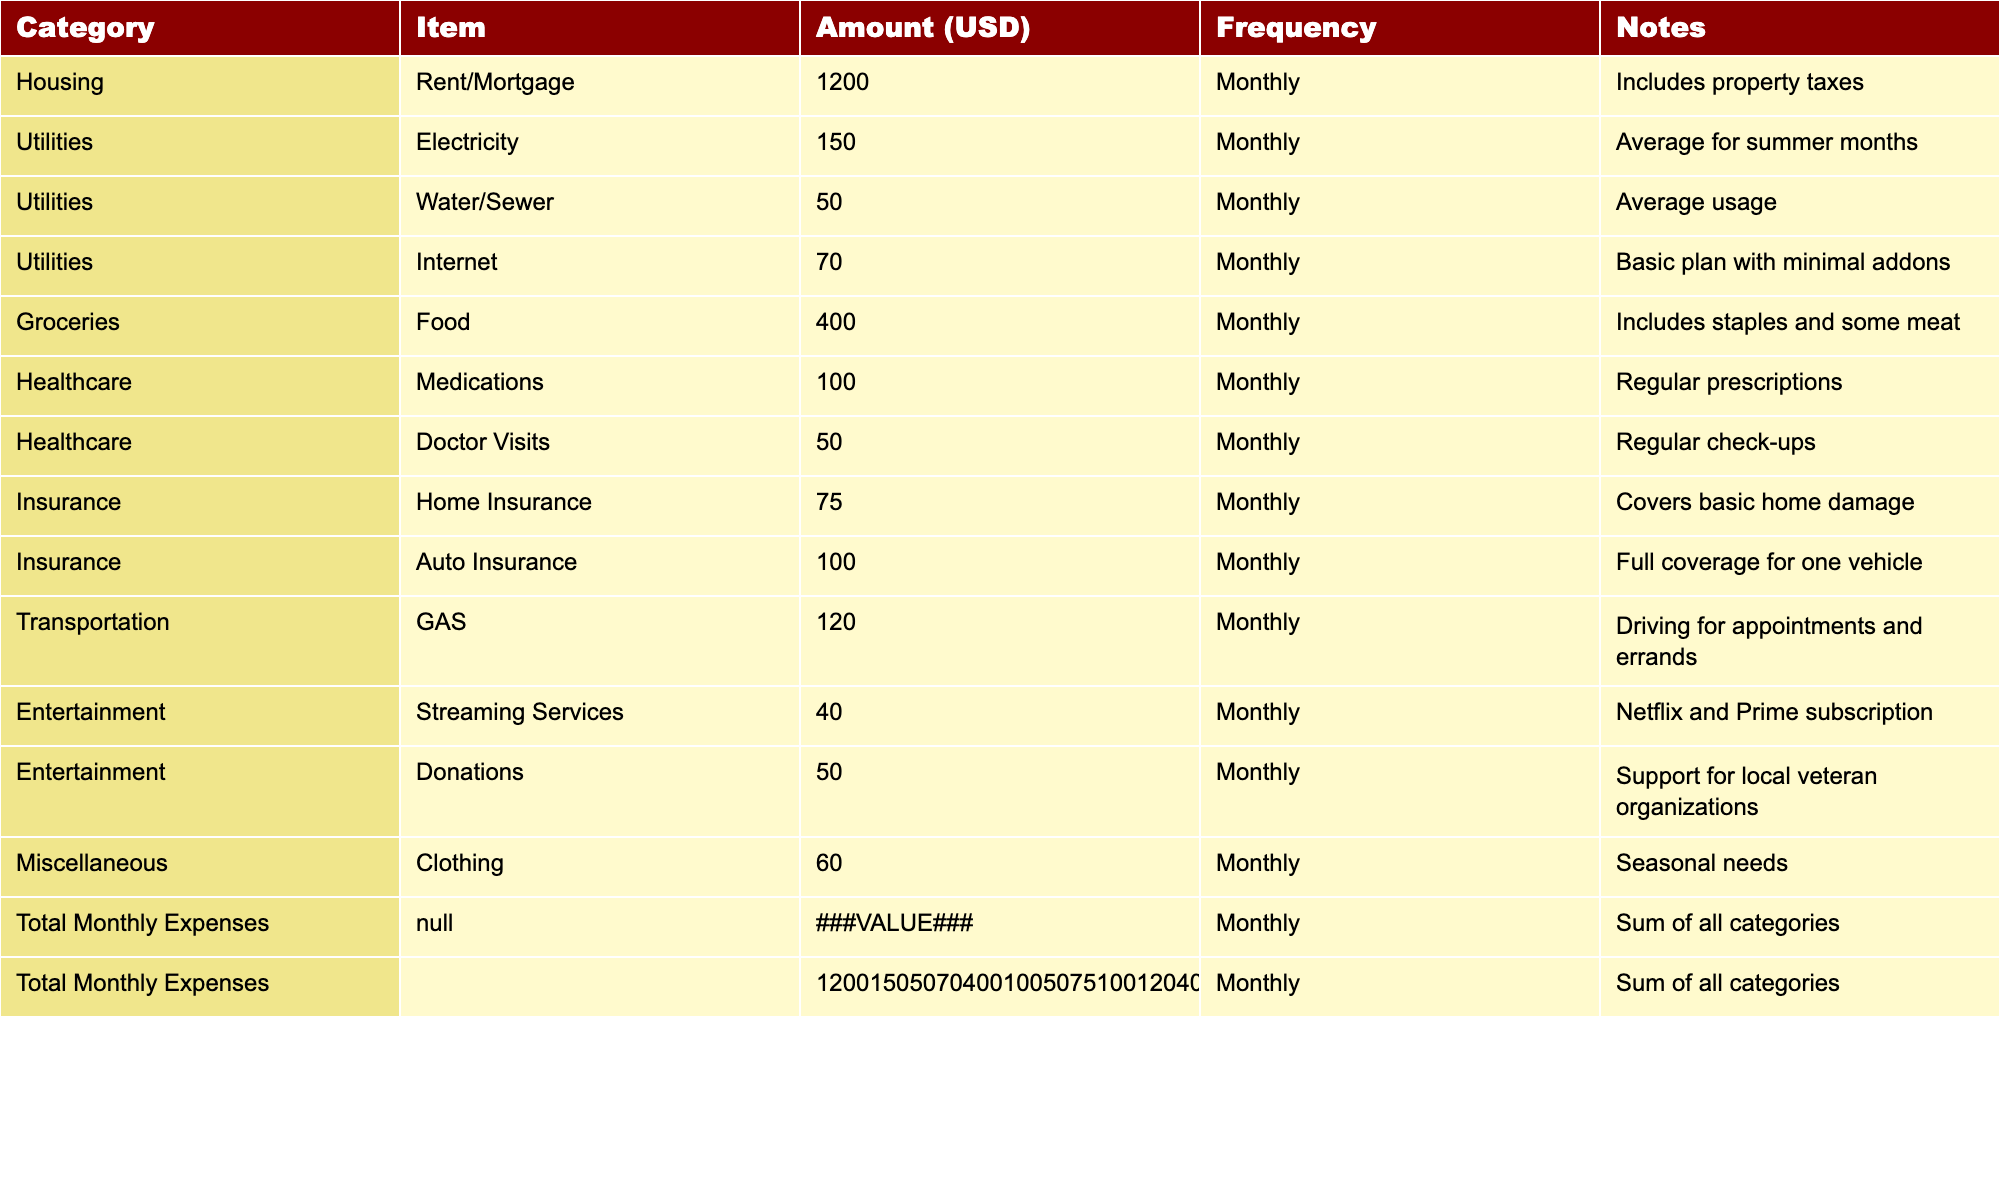What's the total amount for Groceries? The table shows that the amount listed under Groceries for Food is 400 USD.
Answer: 400 USD What is the monthly expense for Auto Insurance? The table indicates that Auto Insurance costs 100 USD a month.
Answer: 100 USD How much more is spent on Healthcare compared to Utilities? Total Healthcare costs = Medications (100 USD) + Doctor Visits (50 USD) = 150 USD; Total Utilities costs = Electricity (150 USD) + Water/Sewer (50 USD) + Internet (70 USD) = 270 USD. Difference = 150 - 270 = -120, so more is spent on Utilities.
Answer: 120 USD more is spent on Utilities What is the total monthly expense for the household? The total amount is calculated by summing all individual expenses, which is 1200 + 150 + 50 + 70 + 400 + 100 + 50 + 75 + 100 + 120 + 40 + 50 + 60 = 2115 USD.
Answer: 2115 USD Is the amount spent on Transportation greater than that for Entertainment? Total spent on Transportation is 120 USD (GAS) and for Entertainment is 40 USD (Streaming Services) + 50 USD (Donations) = 90 USD. Since 120 > 90, the statement is true.
Answer: Yes What percentage of the total monthly expenses is allocated to Groceries? Total expenses are 2115 USD; Groceries are 400 USD, so the percentage is (400/2115) * 100 = approximately 18.9%.
Answer: 18.9% If the Electricity bill increases by 20%, what will be the new amount? The current Electricity bill is 150 USD. A 20% increase would be calculated as 150 * 0.2 = 30, so the new bill would be 150 + 30 = 180 USD.
Answer: 180 USD How much is spent on clothing monthly compared to donations? Clothing expenses are 60 USD and donations are 50 USD. Difference = 60 - 50 = 10, so more is spent on clothing.
Answer: 10 USD more is spent on clothing Is the sum of all Insurance expenses greater than the total transportation expense? Total Insurance is Home Insurance (75 USD) + Auto Insurance (100 USD) = 175 USD; Transportation (GAS) is 120 USD. Since 175 > 120, yes it is.
Answer: Yes What is the total monthly expense for Services (Utilities + Healthcare + Insurance)? Total for Utilities = 150 + 50 + 70 = 270 USD; Total for Healthcare = 100 + 50 = 150 USD; Total for Insurance = 75 + 100 = 175 USD. Sum = 270 + 150 + 175 = 595 USD.
Answer: 595 USD 